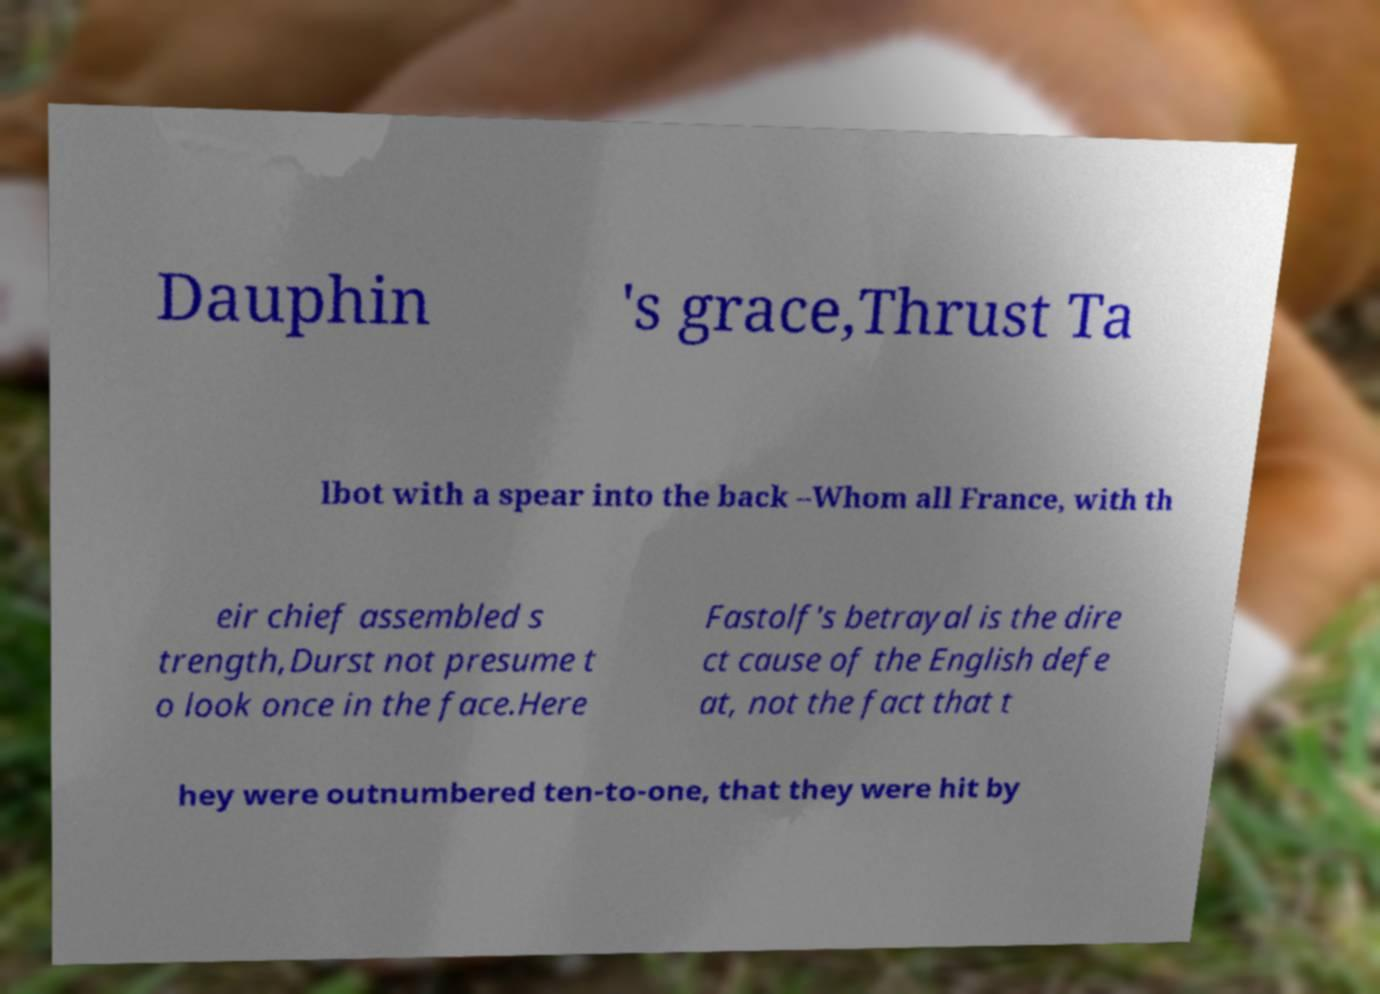Can you accurately transcribe the text from the provided image for me? Dauphin 's grace,Thrust Ta lbot with a spear into the back –Whom all France, with th eir chief assembled s trength,Durst not presume t o look once in the face.Here Fastolf's betrayal is the dire ct cause of the English defe at, not the fact that t hey were outnumbered ten-to-one, that they were hit by 